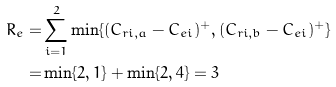<formula> <loc_0><loc_0><loc_500><loc_500>R _ { e } = & \sum _ { i = 1 } ^ { 2 } \min \{ ( C _ { r i , a } - C _ { e i } ) ^ { + } , ( C _ { r i , b } - C _ { e i } ) ^ { + } \} \\ = & \min \{ 2 , 1 \} + \min \{ 2 , 4 \} = 3</formula> 